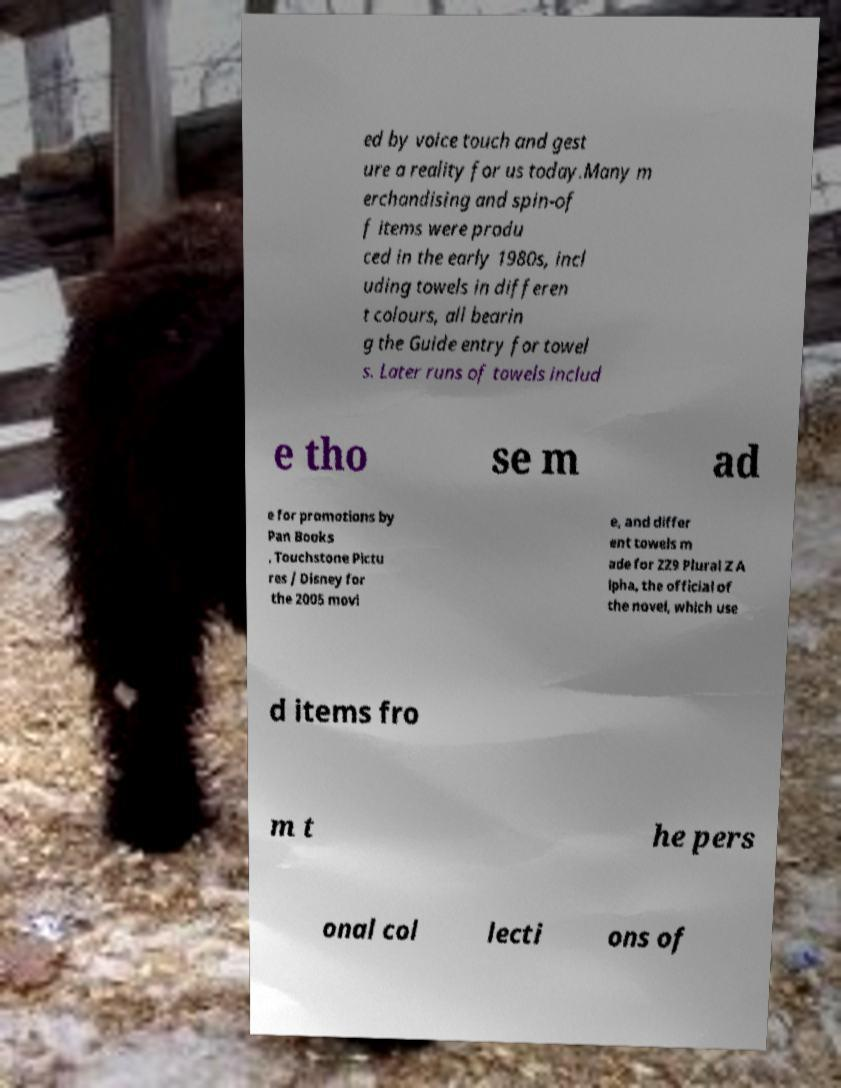Can you accurately transcribe the text from the provided image for me? ed by voice touch and gest ure a reality for us today.Many m erchandising and spin-of f items were produ ced in the early 1980s, incl uding towels in differen t colours, all bearin g the Guide entry for towel s. Later runs of towels includ e tho se m ad e for promotions by Pan Books , Touchstone Pictu res / Disney for the 2005 movi e, and differ ent towels m ade for ZZ9 Plural Z A lpha, the official of the novel, which use d items fro m t he pers onal col lecti ons of 